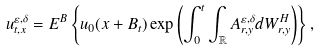<formula> <loc_0><loc_0><loc_500><loc_500>u _ { t , x } ^ { \varepsilon , \delta } = E ^ { B } \left \{ u _ { 0 } ( x + B _ { t } ) \exp \left ( \int _ { 0 } ^ { t } \int _ { \mathbb { R } } A _ { r , y } ^ { \varepsilon , \delta } d W _ { r , y } ^ { H } \right ) \right \} ,</formula> 